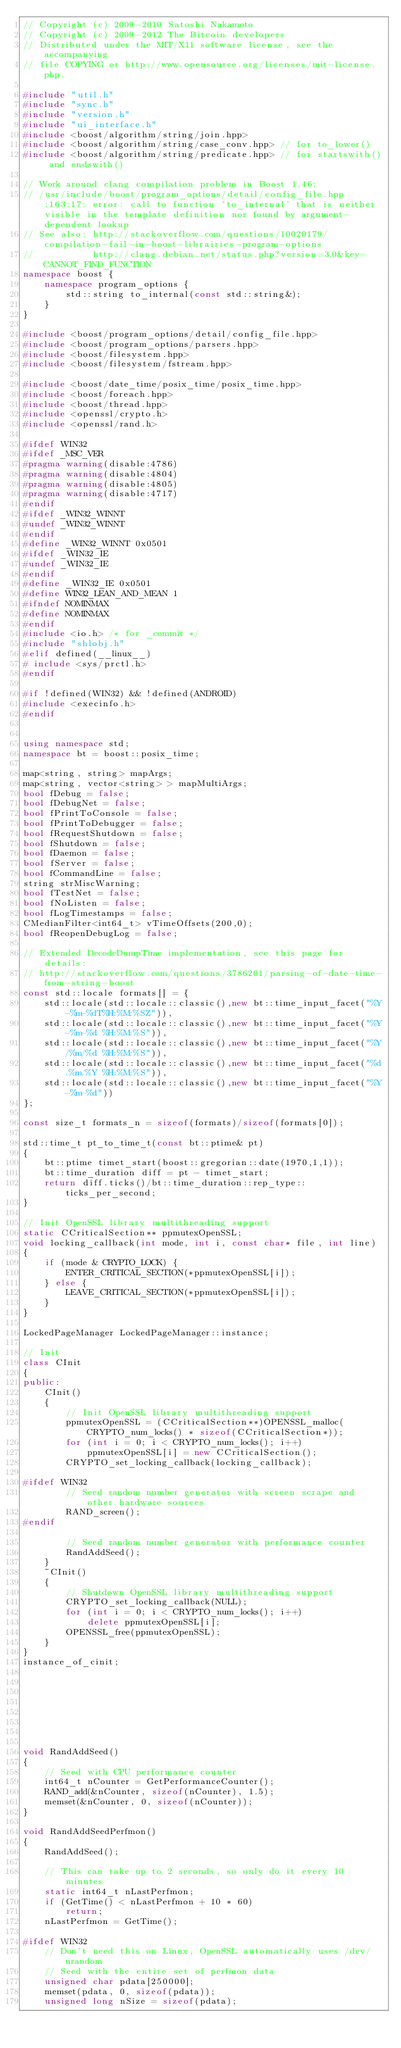Convert code to text. <code><loc_0><loc_0><loc_500><loc_500><_C++_>// Copyright (c) 2009-2010 Satoshi Nakamoto
// Copyright (c) 2009-2012 The Bitcoin developers
// Distributed under the MIT/X11 software license, see the accompanying
// file COPYING or http://www.opensource.org/licenses/mit-license.php.

#include "util.h"
#include "sync.h"
#include "version.h"
#include "ui_interface.h"
#include <boost/algorithm/string/join.hpp>
#include <boost/algorithm/string/case_conv.hpp> // for to_lower()
#include <boost/algorithm/string/predicate.hpp> // for startswith() and endswith()

// Work around clang compilation problem in Boost 1.46:
// /usr/include/boost/program_options/detail/config_file.hpp:163:17: error: call to function 'to_internal' that is neither visible in the template definition nor found by argument-dependent lookup
// See also: http://stackoverflow.com/questions/10020179/compilation-fail-in-boost-librairies-program-options
//           http://clang.debian.net/status.php?version=3.0&key=CANNOT_FIND_FUNCTION
namespace boost {
    namespace program_options {
        std::string to_internal(const std::string&);
    }
}

#include <boost/program_options/detail/config_file.hpp>
#include <boost/program_options/parsers.hpp>
#include <boost/filesystem.hpp>
#include <boost/filesystem/fstream.hpp>

#include <boost/date_time/posix_time/posix_time.hpp>
#include <boost/foreach.hpp>
#include <boost/thread.hpp>
#include <openssl/crypto.h>
#include <openssl/rand.h>

#ifdef WIN32
#ifdef _MSC_VER
#pragma warning(disable:4786)
#pragma warning(disable:4804)
#pragma warning(disable:4805)
#pragma warning(disable:4717)
#endif
#ifdef _WIN32_WINNT
#undef _WIN32_WINNT
#endif
#define _WIN32_WINNT 0x0501
#ifdef _WIN32_IE
#undef _WIN32_IE
#endif
#define _WIN32_IE 0x0501
#define WIN32_LEAN_AND_MEAN 1
#ifndef NOMINMAX
#define NOMINMAX
#endif
#include <io.h> /* for _commit */
#include "shlobj.h"
#elif defined(__linux__)
# include <sys/prctl.h>
#endif

#if !defined(WIN32) && !defined(ANDROID)
#include <execinfo.h>
#endif


using namespace std;
namespace bt = boost::posix_time;

map<string, string> mapArgs;
map<string, vector<string> > mapMultiArgs;
bool fDebug = false;
bool fDebugNet = false;
bool fPrintToConsole = false;
bool fPrintToDebugger = false;
bool fRequestShutdown = false;
bool fShutdown = false;
bool fDaemon = false;
bool fServer = false;
bool fCommandLine = false;
string strMiscWarning;
bool fTestNet = false;
bool fNoListen = false;
bool fLogTimestamps = false;
CMedianFilter<int64_t> vTimeOffsets(200,0);
bool fReopenDebugLog = false;

// Extended DecodeDumpTime implementation, see this page for details:
// http://stackoverflow.com/questions/3786201/parsing-of-date-time-from-string-boost
const std::locale formats[] = {
    std::locale(std::locale::classic(),new bt::time_input_facet("%Y-%m-%dT%H:%M:%SZ")),
    std::locale(std::locale::classic(),new bt::time_input_facet("%Y-%m-%d %H:%M:%S")),
    std::locale(std::locale::classic(),new bt::time_input_facet("%Y/%m/%d %H:%M:%S")),
    std::locale(std::locale::classic(),new bt::time_input_facet("%d.%m.%Y %H:%M:%S")),
    std::locale(std::locale::classic(),new bt::time_input_facet("%Y-%m-%d"))
};

const size_t formats_n = sizeof(formats)/sizeof(formats[0]);

std::time_t pt_to_time_t(const bt::ptime& pt)
{
    bt::ptime timet_start(boost::gregorian::date(1970,1,1));
    bt::time_duration diff = pt - timet_start;
    return diff.ticks()/bt::time_duration::rep_type::ticks_per_second;
}

// Init OpenSSL library multithreading support
static CCriticalSection** ppmutexOpenSSL;
void locking_callback(int mode, int i, const char* file, int line)
{
    if (mode & CRYPTO_LOCK) {
        ENTER_CRITICAL_SECTION(*ppmutexOpenSSL[i]);
    } else {
        LEAVE_CRITICAL_SECTION(*ppmutexOpenSSL[i]);
    }
}

LockedPageManager LockedPageManager::instance;

// Init
class CInit
{
public:
    CInit()
    {
        // Init OpenSSL library multithreading support
        ppmutexOpenSSL = (CCriticalSection**)OPENSSL_malloc(CRYPTO_num_locks() * sizeof(CCriticalSection*));
        for (int i = 0; i < CRYPTO_num_locks(); i++)
            ppmutexOpenSSL[i] = new CCriticalSection();
        CRYPTO_set_locking_callback(locking_callback);

#ifdef WIN32
        // Seed random number generator with screen scrape and other hardware sources
        RAND_screen();
#endif

        // Seed random number generator with performance counter
        RandAddSeed();
    }
    ~CInit()
    {
        // Shutdown OpenSSL library multithreading support
        CRYPTO_set_locking_callback(NULL);
        for (int i = 0; i < CRYPTO_num_locks(); i++)
            delete ppmutexOpenSSL[i];
        OPENSSL_free(ppmutexOpenSSL);
    }
}
instance_of_cinit;








void RandAddSeed()
{
    // Seed with CPU performance counter
    int64_t nCounter = GetPerformanceCounter();
    RAND_add(&nCounter, sizeof(nCounter), 1.5);
    memset(&nCounter, 0, sizeof(nCounter));
}

void RandAddSeedPerfmon()
{
    RandAddSeed();

    // This can take up to 2 seconds, so only do it every 10 minutes
    static int64_t nLastPerfmon;
    if (GetTime() < nLastPerfmon + 10 * 60)
        return;
    nLastPerfmon = GetTime();

#ifdef WIN32
    // Don't need this on Linux, OpenSSL automatically uses /dev/urandom
    // Seed with the entire set of perfmon data
    unsigned char pdata[250000];
    memset(pdata, 0, sizeof(pdata));
    unsigned long nSize = sizeof(pdata);</code> 